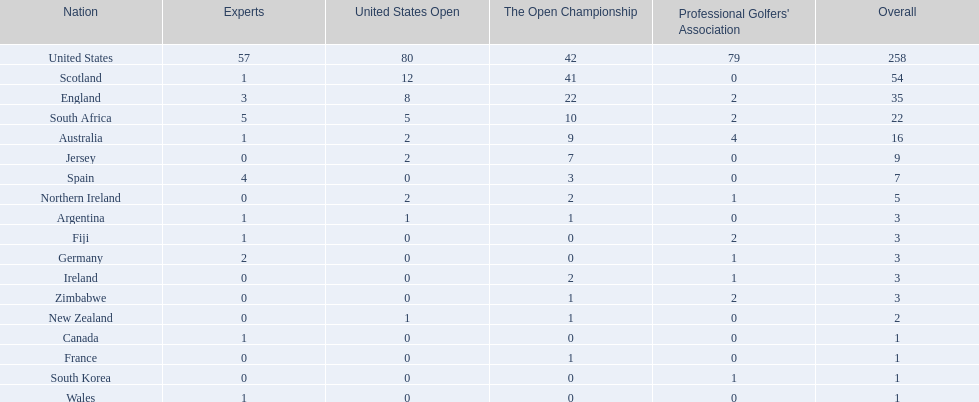What are all the countries? United States, Scotland, England, South Africa, Australia, Jersey, Spain, Northern Ireland, Argentina, Fiji, Germany, Ireland, Zimbabwe, New Zealand, Canada, France, South Korea, Wales. Which ones are located in africa? South Africa, Zimbabwe. Of those, which has the least champion golfers? Zimbabwe. 